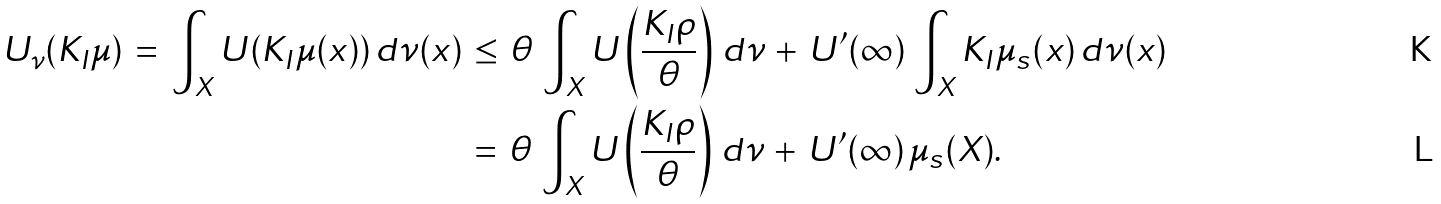Convert formula to latex. <formula><loc_0><loc_0><loc_500><loc_500>U _ { \nu } ( K _ { I } \mu ) \, = \, \int _ { X } U ( K _ { I } \mu ( x ) ) \, d \nu ( x ) \, & \leq \, \theta \, \int _ { X } U \left ( \frac { K _ { I } \rho } { \theta } \right ) \, d \nu \, + \, U ^ { \prime } ( \infty ) \, \int _ { X } K _ { I } \mu _ { s } ( x ) \, d \nu ( x ) \\ & = \, \theta \, \int _ { X } U \left ( \frac { K _ { I } \rho } { \theta } \right ) \, d \nu \, + \, U ^ { \prime } ( \infty ) \, \mu _ { s } ( X ) .</formula> 